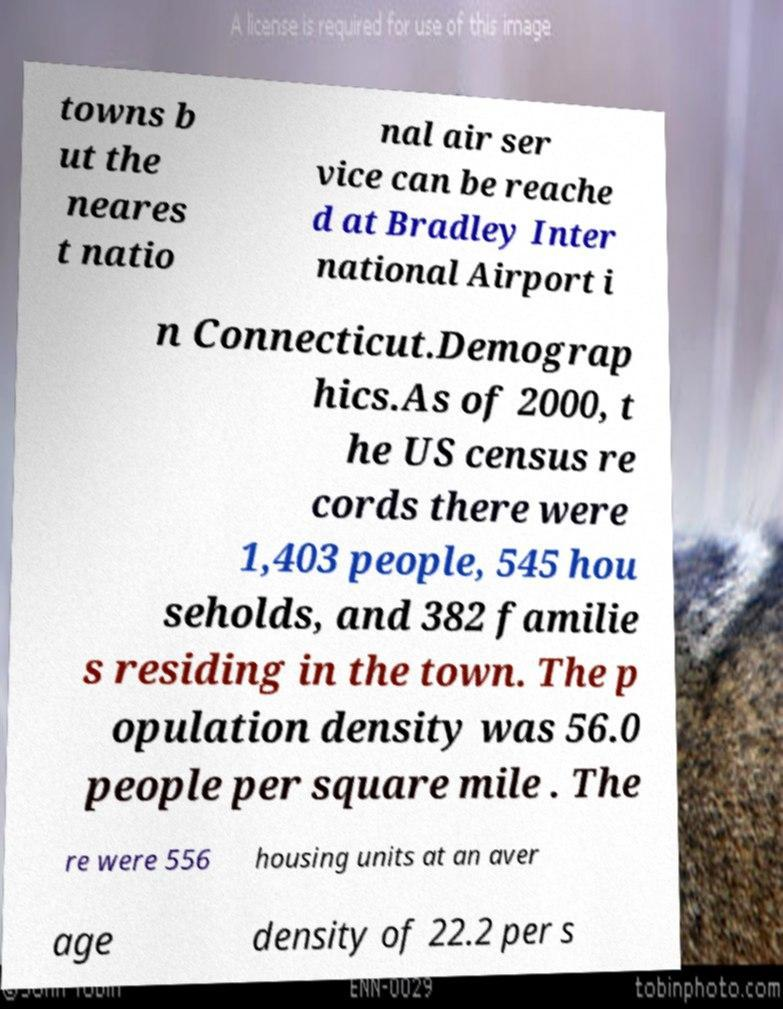Can you read and provide the text displayed in the image?This photo seems to have some interesting text. Can you extract and type it out for me? towns b ut the neares t natio nal air ser vice can be reache d at Bradley Inter national Airport i n Connecticut.Demograp hics.As of 2000, t he US census re cords there were 1,403 people, 545 hou seholds, and 382 familie s residing in the town. The p opulation density was 56.0 people per square mile . The re were 556 housing units at an aver age density of 22.2 per s 